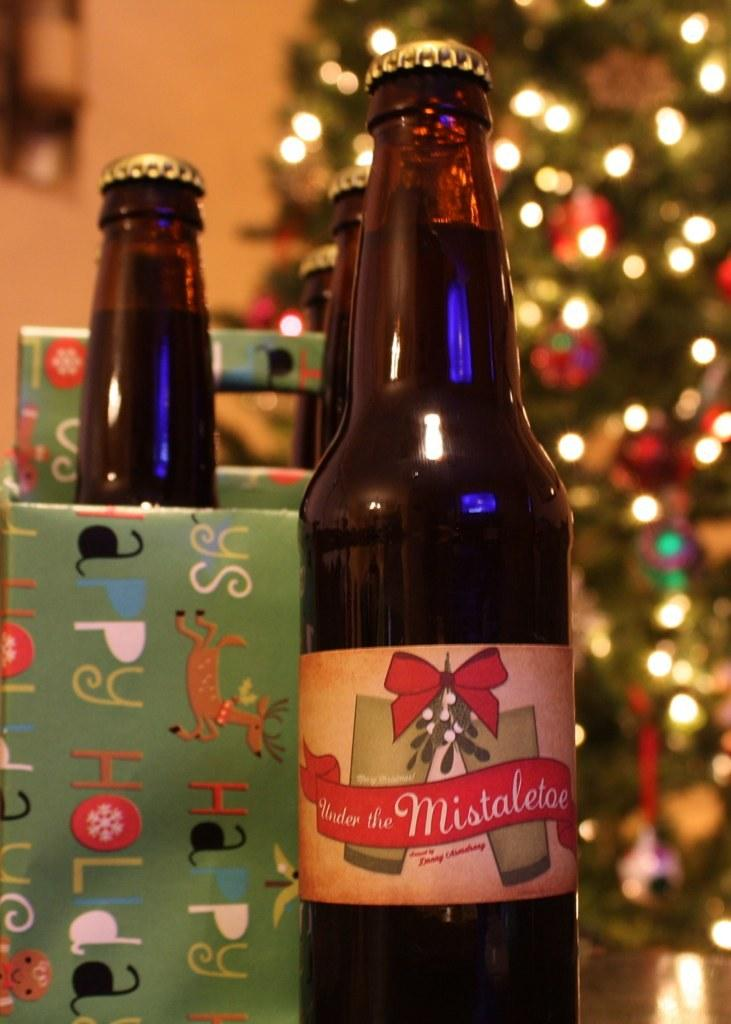<image>
Describe the image concisely. a bottle of alcohol labeled 'under the mistletoe' in front of a christmas tree 